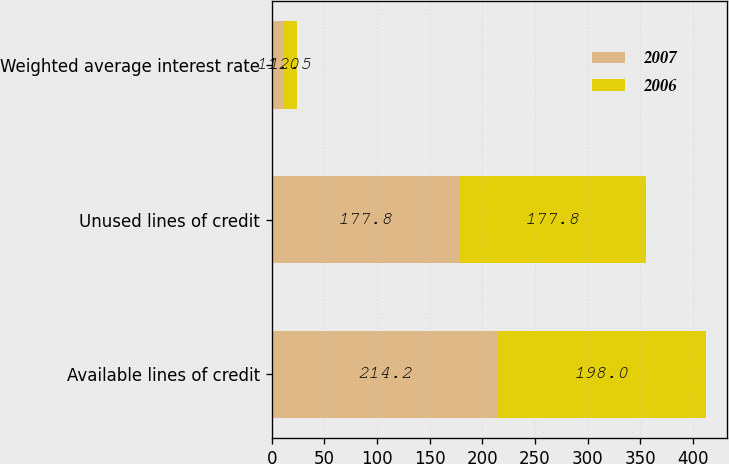<chart> <loc_0><loc_0><loc_500><loc_500><stacked_bar_chart><ecel><fcel>Available lines of credit<fcel>Unused lines of credit<fcel>Weighted average interest rate<nl><fcel>2007<fcel>214.2<fcel>177.8<fcel>11<nl><fcel>2006<fcel>198<fcel>177.8<fcel>12.5<nl></chart> 